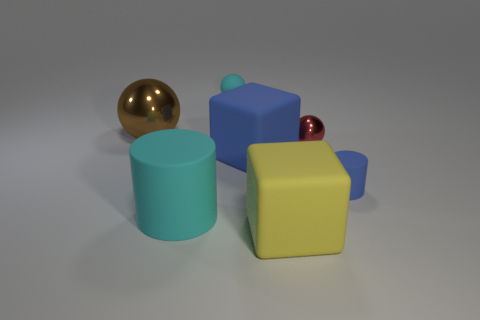What shape is the thing that is the same color as the matte sphere?
Provide a succinct answer. Cylinder. How many other things are there of the same shape as the big blue object?
Provide a succinct answer. 1. Are there more cylinders behind the large brown thing than big cyan rubber cylinders?
Provide a succinct answer. No. There is a tiny ball that is on the right side of the small cyan ball; what color is it?
Offer a very short reply. Red. There is a matte cube that is the same color as the tiny cylinder; what size is it?
Keep it short and to the point. Large. What number of metallic objects are tiny things or big gray spheres?
Ensure brevity in your answer.  1. There is a large block on the left side of the rubber block that is in front of the big blue matte object; is there a brown metal sphere in front of it?
Your response must be concise. No. How many large brown spheres are behind the rubber sphere?
Keep it short and to the point. 0. There is a thing that is the same color as the small matte ball; what is its material?
Provide a succinct answer. Rubber. What number of small things are either cyan spheres or green metal spheres?
Your response must be concise. 1. 